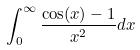<formula> <loc_0><loc_0><loc_500><loc_500>\int _ { 0 } ^ { \infty } \frac { \cos ( x ) - 1 } { x ^ { 2 } } d x</formula> 